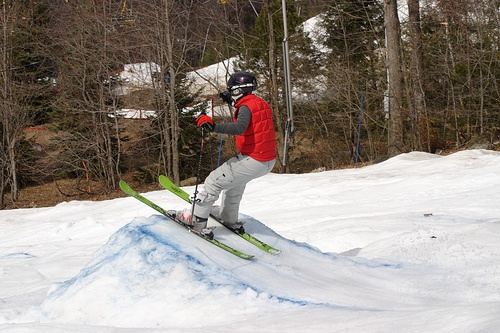Describe the objects in this image and their specific colors. I can see people in black, darkgray, gray, and brown tones, skis in black, olive, and lightgray tones, and skis in black, olive, gray, and darkgray tones in this image. 